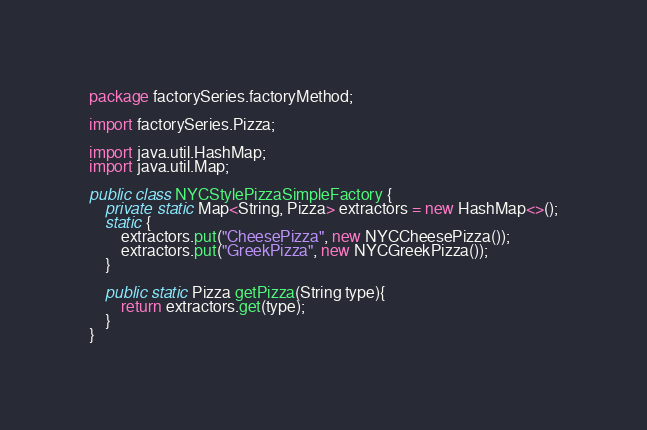<code> <loc_0><loc_0><loc_500><loc_500><_Java_>package factorySeries.factoryMethod;

import factorySeries.Pizza;

import java.util.HashMap;
import java.util.Map;

public class NYCStylePizzaSimpleFactory {
    private static Map<String, Pizza> extractors = new HashMap<>();
    static {
        extractors.put("CheesePizza", new NYCCheesePizza());
        extractors.put("GreekPizza", new NYCGreekPizza());
    }

    public static Pizza getPizza(String type){
        return extractors.get(type);
    }
}
</code> 